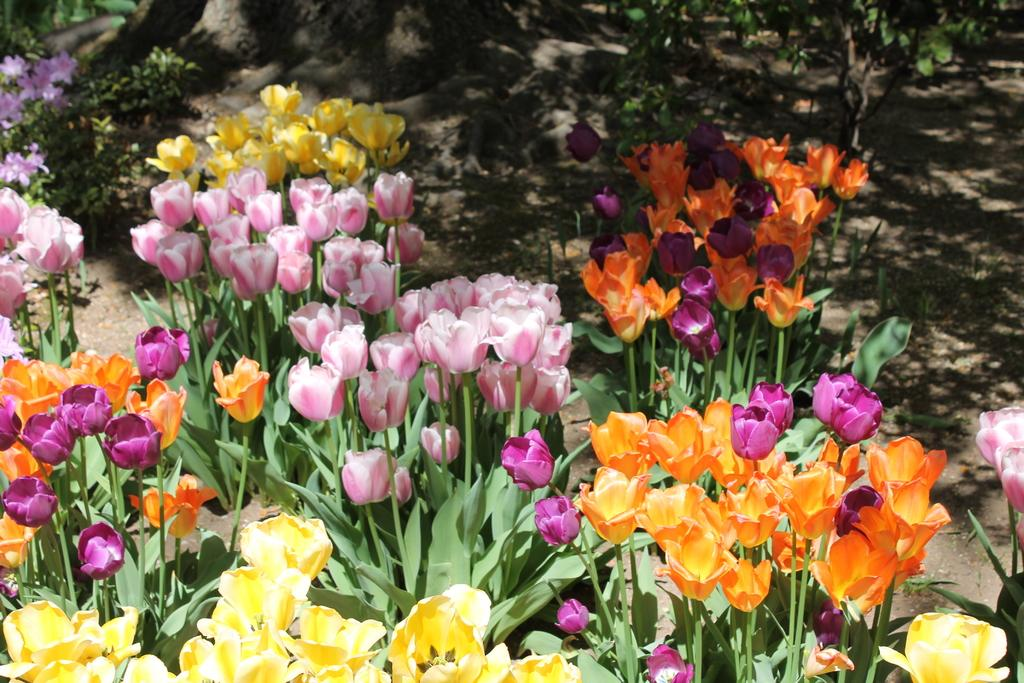What type of flora can be seen in the image? There are flowers in the image. Can you describe the colors of the flowers? The flowers have different colors, including yellow, pink, and red. What else can be seen in the background of the image? There are plants in the background of the image. Can you see any ghosts interacting with the flowers in the image? There are no ghosts present in the image; it features flowers and plants. What type of transportation can be seen at the airport in the image? There is no airport or transportation present in the image; it features flowers and plants. 